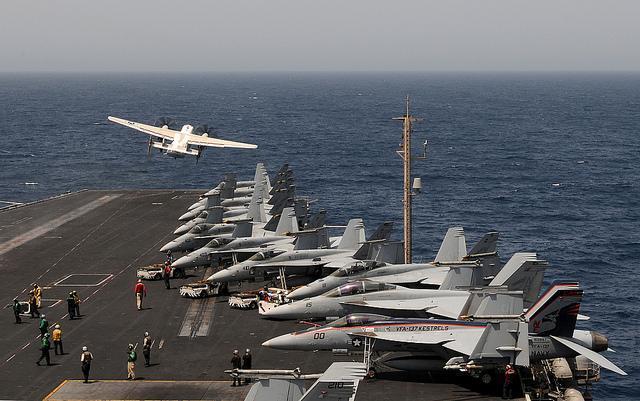How many planes are in the air?
Give a very brief answer. 1. How many planes are shown?
Give a very brief answer. 11. How many airplanes are there?
Give a very brief answer. 6. 